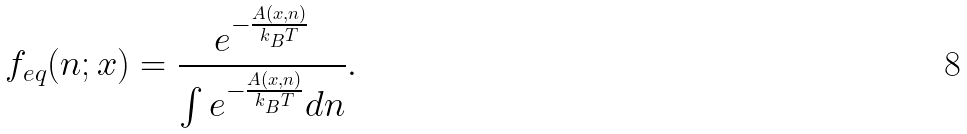Convert formula to latex. <formula><loc_0><loc_0><loc_500><loc_500>f _ { e q } ( n ; x ) = \frac { e ^ { - \frac { A ( x , n ) } { k _ { B } T } } } { \int e ^ { - \frac { A ( x , n ) } { k _ { B } T } } d n } .</formula> 